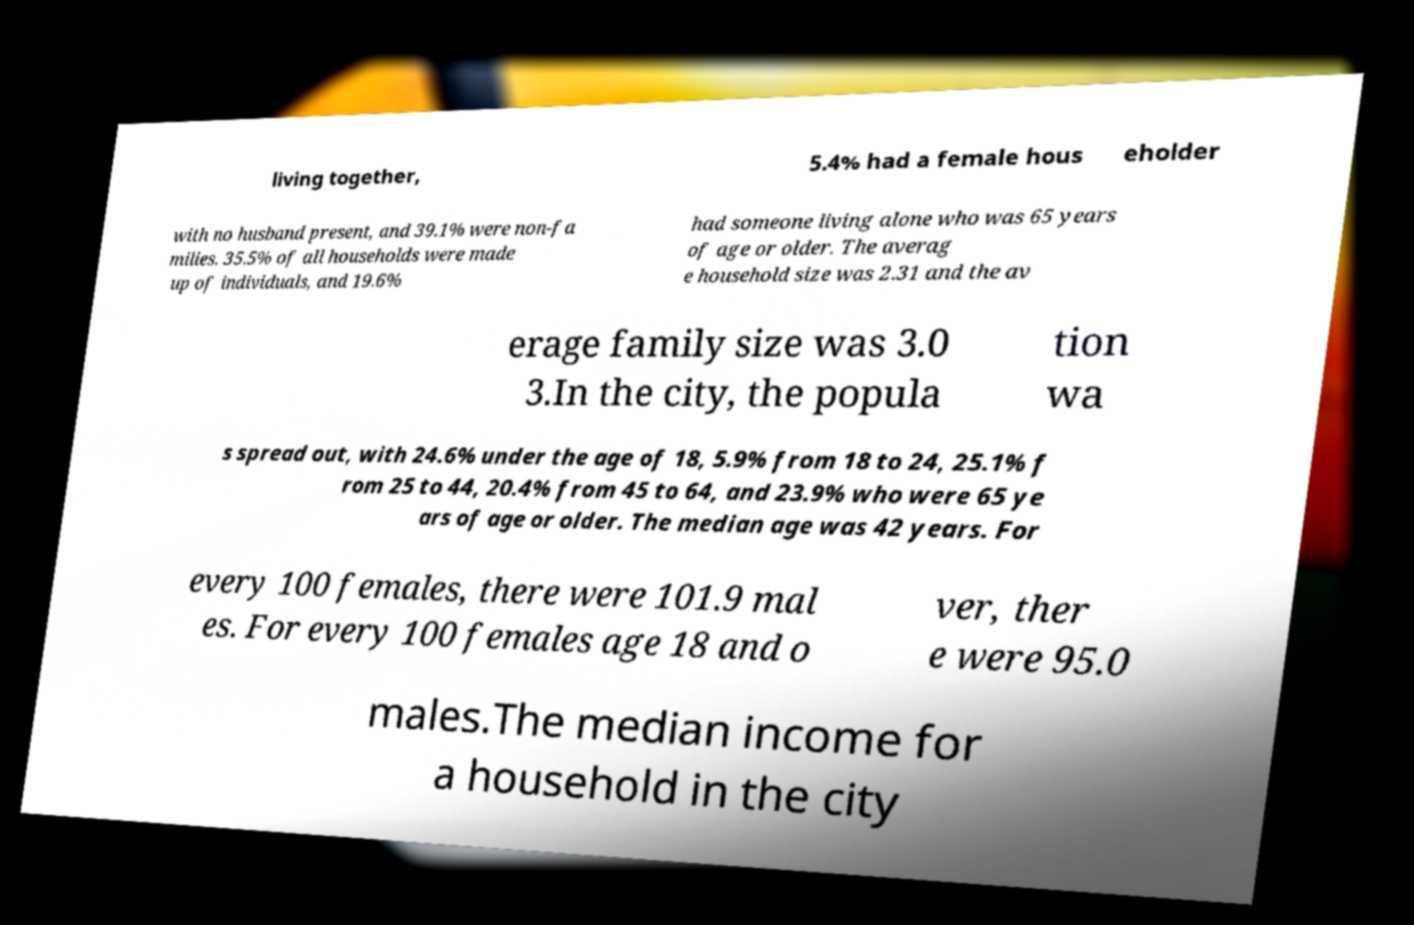Can you read and provide the text displayed in the image?This photo seems to have some interesting text. Can you extract and type it out for me? living together, 5.4% had a female hous eholder with no husband present, and 39.1% were non-fa milies. 35.5% of all households were made up of individuals, and 19.6% had someone living alone who was 65 years of age or older. The averag e household size was 2.31 and the av erage family size was 3.0 3.In the city, the popula tion wa s spread out, with 24.6% under the age of 18, 5.9% from 18 to 24, 25.1% f rom 25 to 44, 20.4% from 45 to 64, and 23.9% who were 65 ye ars of age or older. The median age was 42 years. For every 100 females, there were 101.9 mal es. For every 100 females age 18 and o ver, ther e were 95.0 males.The median income for a household in the city 